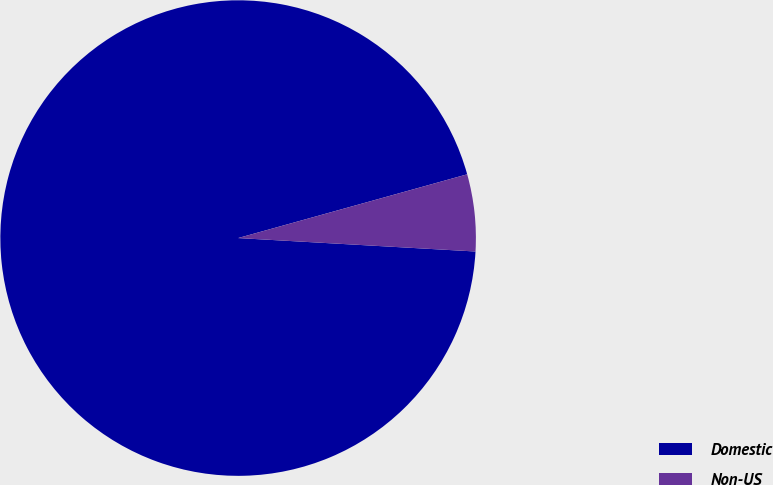Convert chart to OTSL. <chart><loc_0><loc_0><loc_500><loc_500><pie_chart><fcel>Domestic<fcel>Non-US<nl><fcel>94.78%<fcel>5.22%<nl></chart> 